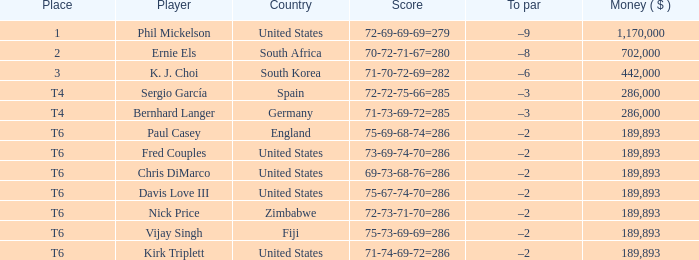Would you mind parsing the complete table? {'header': ['Place', 'Player', 'Country', 'Score', 'To par', 'Money ( $ )'], 'rows': [['1', 'Phil Mickelson', 'United States', '72-69-69-69=279', '–9', '1,170,000'], ['2', 'Ernie Els', 'South Africa', '70-72-71-67=280', '–8', '702,000'], ['3', 'K. J. Choi', 'South Korea', '71-70-72-69=282', '–6', '442,000'], ['T4', 'Sergio García', 'Spain', '72-72-75-66=285', '–3', '286,000'], ['T4', 'Bernhard Langer', 'Germany', '71-73-69-72=285', '–3', '286,000'], ['T6', 'Paul Casey', 'England', '75-69-68-74=286', '–2', '189,893'], ['T6', 'Fred Couples', 'United States', '73-69-74-70=286', '–2', '189,893'], ['T6', 'Chris DiMarco', 'United States', '69-73-68-76=286', '–2', '189,893'], ['T6', 'Davis Love III', 'United States', '75-67-74-70=286', '–2', '189,893'], ['T6', 'Nick Price', 'Zimbabwe', '72-73-71-70=286', '–2', '189,893'], ['T6', 'Vijay Singh', 'Fiji', '75-73-69-69=286', '–2', '189,893'], ['T6', 'Kirk Triplett', 'United States', '71-74-69-72=286', '–2', '189,893']]} What is the most money ($) when the score is 71-74-69-72=286? 189893.0. 